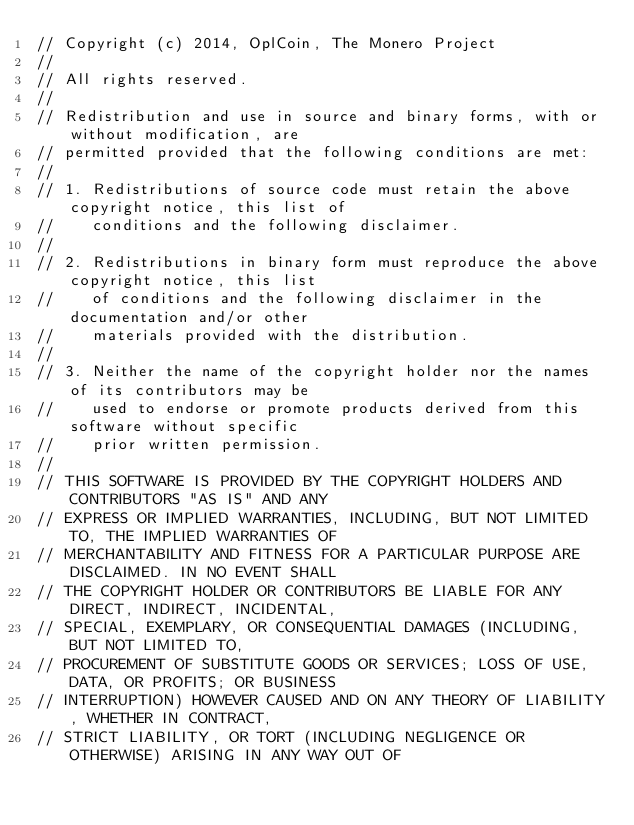<code> <loc_0><loc_0><loc_500><loc_500><_C++_>// Copyright (c) 2014, OplCoin, The Monero Project
// 
// All rights reserved.
// 
// Redistribution and use in source and binary forms, with or without modification, are
// permitted provided that the following conditions are met:
// 
// 1. Redistributions of source code must retain the above copyright notice, this list of
//    conditions and the following disclaimer.
// 
// 2. Redistributions in binary form must reproduce the above copyright notice, this list
//    of conditions and the following disclaimer in the documentation and/or other
//    materials provided with the distribution.
// 
// 3. Neither the name of the copyright holder nor the names of its contributors may be
//    used to endorse or promote products derived from this software without specific
//    prior written permission.
// 
// THIS SOFTWARE IS PROVIDED BY THE COPYRIGHT HOLDERS AND CONTRIBUTORS "AS IS" AND ANY
// EXPRESS OR IMPLIED WARRANTIES, INCLUDING, BUT NOT LIMITED TO, THE IMPLIED WARRANTIES OF
// MERCHANTABILITY AND FITNESS FOR A PARTICULAR PURPOSE ARE DISCLAIMED. IN NO EVENT SHALL
// THE COPYRIGHT HOLDER OR CONTRIBUTORS BE LIABLE FOR ANY DIRECT, INDIRECT, INCIDENTAL,
// SPECIAL, EXEMPLARY, OR CONSEQUENTIAL DAMAGES (INCLUDING, BUT NOT LIMITED TO,
// PROCUREMENT OF SUBSTITUTE GOODS OR SERVICES; LOSS OF USE, DATA, OR PROFITS; OR BUSINESS
// INTERRUPTION) HOWEVER CAUSED AND ON ANY THEORY OF LIABILITY, WHETHER IN CONTRACT,
// STRICT LIABILITY, OR TORT (INCLUDING NEGLIGENCE OR OTHERWISE) ARISING IN ANY WAY OUT OF</code> 